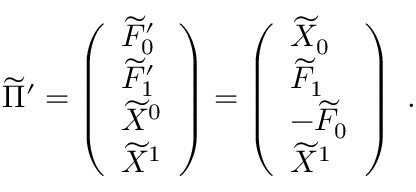Convert formula to latex. <formula><loc_0><loc_0><loc_500><loc_500>\widetilde { \Pi } ^ { \prime } = \left ( \begin{array} { l } { { \widetilde { F } _ { 0 } ^ { \prime } } } \\ { { \widetilde { F } _ { 1 } ^ { \prime } } } \\ { { \widetilde { X } ^ { 0 } } } \\ { { \widetilde { X } ^ { 1 } } } \end{array} \right ) = \left ( \begin{array} { l } { { \widetilde { X } _ { 0 } } } \\ { { \widetilde { F } _ { 1 } } } \\ { { - \widetilde { F } _ { 0 } } } \\ { { \widetilde { X } ^ { 1 } } } \end{array} \right ) \ .</formula> 